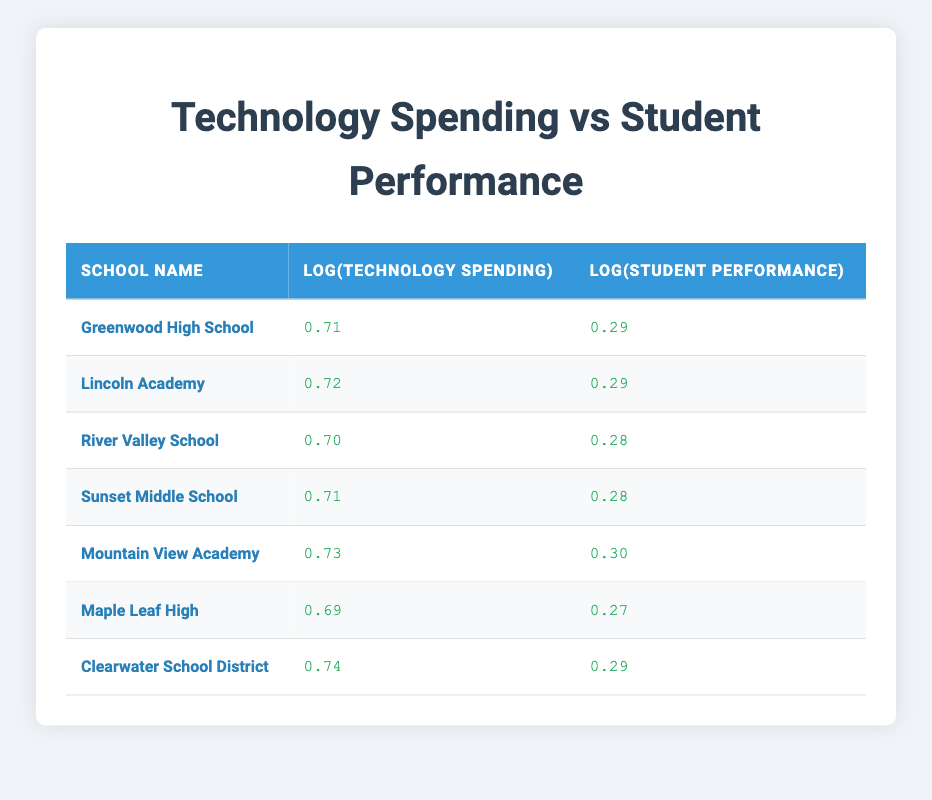What is the technology spending for Mountain View Academy? The table lists Mountain View Academy with a technology spending value. By looking directly at the row for this school, I find the technology spending mentioned as 250000.
Answer: 250000 Which school has the highest student performance metric? To determine this, I need to review the student performance metrics listed in the table and find the maximum value. By comparing the metrics, I see that Mountain View Academy has the highest performance metric at 95.
Answer: Mountain View Academy What is the average logarithmic value of technology spending across the listed schools? I will first add the logarithmic values given in the table for technology spending: 5.18 + 5.30 + 5.00 + 5.08 + 5.40 + 4.90 + 5.48 = 36.34. Then, I divide by the number of schools (7) to find the average: 36.34 / 7 = 5.19.
Answer: 5.19 Is it true that Clearwater School District has higher student performance than Greenwood High School? To verify this, I will compare the student performance metrics listed for both schools in the table. Clearwater has a student performance metric of 92, while Greenwood has a metric of 85. Since 92 is greater than 85, the statement is true.
Answer: Yes What is the difference in logarithmic values for student performance between Lincoln Academy and Maple Leaf High? I will check the logarithmic values for student performance in both schools. Lincoln Academy has a value of 1.95, and Maple Leaf High has a value of 1.88. The difference is calculated as 1.95 - 1.88 = 0.07.
Answer: 0.07 Which school(s) have a technology spending logarithmic value above 5.30? I will examine each school's logarithmic value for technology spending and identify those that exceed 5.30. By checking the values, I find that Lincoln Academy (5.30 excluded), Mountain View Academy (5.40), and Clearwater School District (5.48) exceed this amount.
Answer: Mountain View Academy, Clearwater School District Calculate the total technology spending for all the schools listed. I will sum the technology spending values for each school: 150000 + 200000 + 100000 + 120000 + 250000 + 80000 + 300000 = 1,200,000.
Answer: 1200000 